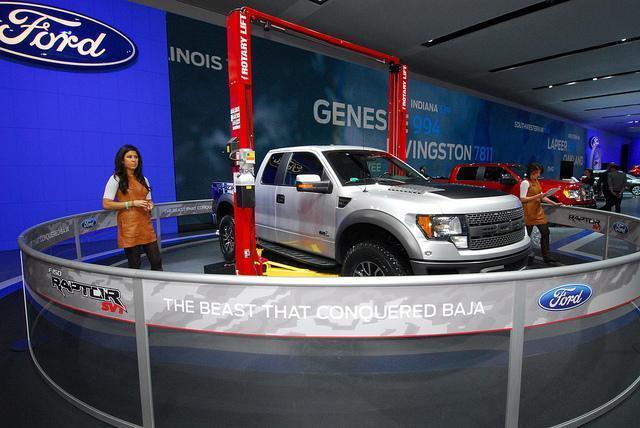How many cars are in the picture?
Give a very brief answer. 1. How many trucks are there?
Give a very brief answer. 2. 